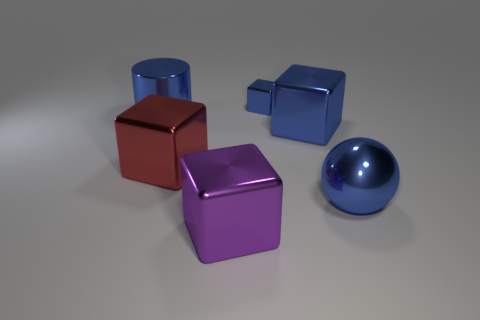What is the material of the large purple object that is the same shape as the red metallic thing?
Give a very brief answer. Metal. Is there anything else that has the same material as the big purple block?
Your answer should be compact. Yes. Is the shiny cylinder the same color as the tiny object?
Provide a short and direct response. Yes. There is a big red object that is the same material as the purple object; what is its shape?
Your answer should be very brief. Cube. How many other big red metal objects have the same shape as the red shiny thing?
Keep it short and to the point. 0. What shape is the blue thing that is in front of the large cube that is behind the large red thing?
Give a very brief answer. Sphere. Do the metal object that is behind the blue metal cylinder and the purple shiny object have the same size?
Provide a short and direct response. No. How big is the object that is in front of the big cylinder and behind the red cube?
Offer a very short reply. Large. How many blue objects have the same size as the blue metal cylinder?
Keep it short and to the point. 2. What number of tiny blue objects are in front of the shiny block that is in front of the big red thing?
Ensure brevity in your answer.  0. 